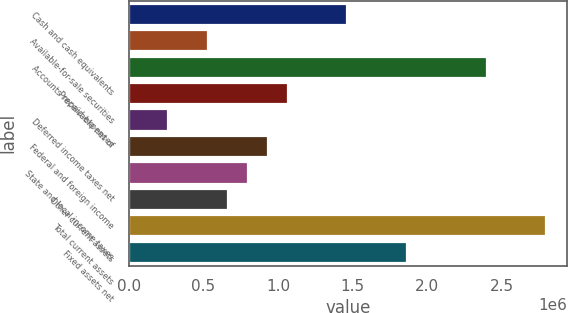Convert chart to OTSL. <chart><loc_0><loc_0><loc_500><loc_500><bar_chart><fcel>Cash and cash equivalents<fcel>Available-for-sale securities<fcel>Accounts receivable net of<fcel>Prepaid expenses<fcel>Deferred income taxes net<fcel>Federal and foreign income<fcel>State and local income taxes<fcel>Other current assets<fcel>Total current assets<fcel>Fixed assets net<nl><fcel>1.46468e+06<fcel>532636<fcel>2.39673e+06<fcel>1.06523e+06<fcel>266338<fcel>932084<fcel>798935<fcel>665786<fcel>2.79617e+06<fcel>1.86413e+06<nl></chart> 